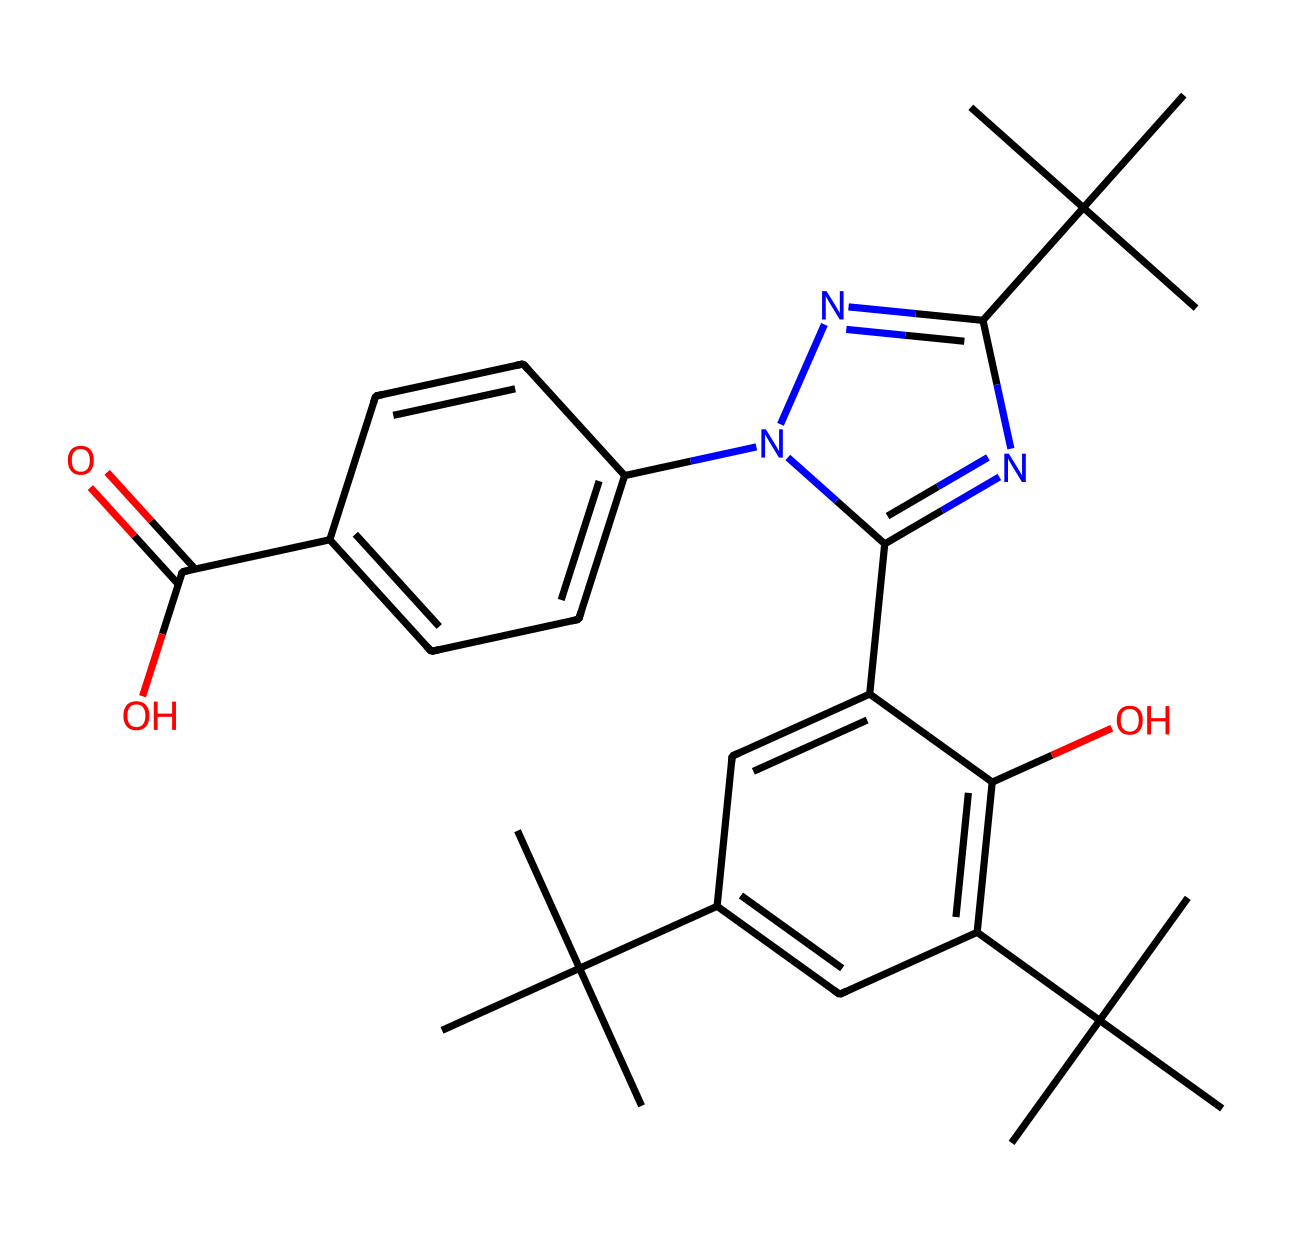What is the molecular weight of this compound? To determine the molecular weight, you would sum the atomic weights of all atoms present in the chemical. From the SMILES representation, identify the elements (C, H, O, N) and count the number of each atom. Calculating this gives a molecular weight of approximately 472.37 g/mol.
Answer: 472.37 g/mol How many carbon atoms are in the chemical structure? By analyzing the SMILES formula, count the number of "C" symbols present. There are 20 carbon atoms in total, including those in branches and rings.
Answer: 20 Does this chemical contain nitrogen atoms? Review the SMILES for the presence of the letter "N." The chemical representation includes nitrogen (N), confirming its presence in the structure.
Answer: yes What functional groups are present in this molecule? Analyze the structure for common functional groups; the most evident are the hydroxyl group (-OH) and carboxylic acid group (-COOH). Identifying these provides insight into its properties.
Answer: hydroxyl and carboxylic acid Is this compound likely to be hydrophilic or hydrophobic? Assess the presence of polar functional groups like -OH and -COOH, which suggest increased solubility in water and indicate hydrophilicity. The multiple carbon atoms do add some hydrophobic character, but overall, it leans towards hydrophilic.
Answer: hydrophilic What type of bond primarily links the carbon atoms? Examine the SMILES for connections between carbon atoms; the typical bond is a single bond (indicated by the absence of any special notation). A few double bonds may exist as well, predominantly single bonds link the carbons.
Answer: single bond 